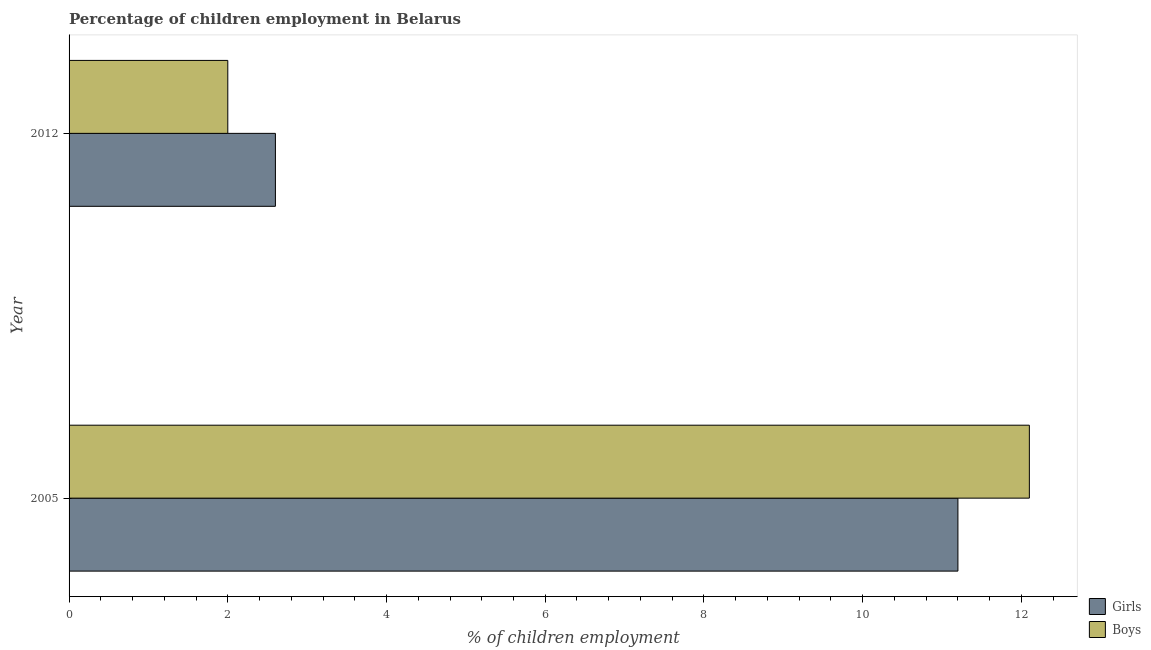How many different coloured bars are there?
Provide a short and direct response. 2. Are the number of bars on each tick of the Y-axis equal?
Make the answer very short. Yes. How many bars are there on the 2nd tick from the top?
Offer a very short reply. 2. How many bars are there on the 2nd tick from the bottom?
Provide a succinct answer. 2. In how many cases, is the number of bars for a given year not equal to the number of legend labels?
Keep it short and to the point. 0. Across all years, what is the maximum percentage of employed girls?
Keep it short and to the point. 11.2. In which year was the percentage of employed boys minimum?
Provide a succinct answer. 2012. What is the total percentage of employed boys in the graph?
Ensure brevity in your answer.  14.1. What is the difference between the percentage of employed boys in 2005 and the percentage of employed girls in 2012?
Your answer should be very brief. 9.5. What is the average percentage of employed boys per year?
Provide a short and direct response. 7.05. In the year 2012, what is the difference between the percentage of employed boys and percentage of employed girls?
Your response must be concise. -0.6. What is the ratio of the percentage of employed girls in 2005 to that in 2012?
Keep it short and to the point. 4.31. What does the 2nd bar from the top in 2005 represents?
Your response must be concise. Girls. What does the 1st bar from the bottom in 2005 represents?
Give a very brief answer. Girls. Are the values on the major ticks of X-axis written in scientific E-notation?
Provide a short and direct response. No. Does the graph contain any zero values?
Offer a terse response. No. Does the graph contain grids?
Provide a short and direct response. No. What is the title of the graph?
Provide a succinct answer. Percentage of children employment in Belarus. What is the label or title of the X-axis?
Provide a short and direct response. % of children employment. What is the % of children employment of Boys in 2012?
Give a very brief answer. 2. Across all years, what is the minimum % of children employment in Boys?
Provide a short and direct response. 2. What is the total % of children employment of Girls in the graph?
Make the answer very short. 13.8. What is the total % of children employment in Boys in the graph?
Provide a short and direct response. 14.1. What is the difference between the % of children employment in Girls in 2005 and that in 2012?
Make the answer very short. 8.6. What is the average % of children employment of Girls per year?
Ensure brevity in your answer.  6.9. What is the average % of children employment in Boys per year?
Your answer should be very brief. 7.05. In the year 2005, what is the difference between the % of children employment in Girls and % of children employment in Boys?
Your answer should be very brief. -0.9. What is the ratio of the % of children employment of Girls in 2005 to that in 2012?
Provide a succinct answer. 4.31. What is the ratio of the % of children employment in Boys in 2005 to that in 2012?
Your response must be concise. 6.05. What is the difference between the highest and the second highest % of children employment in Boys?
Offer a very short reply. 10.1. 